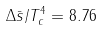<formula> <loc_0><loc_0><loc_500><loc_500>\Delta \bar { s } / T _ { c } ^ { 4 } = 8 . 7 6</formula> 